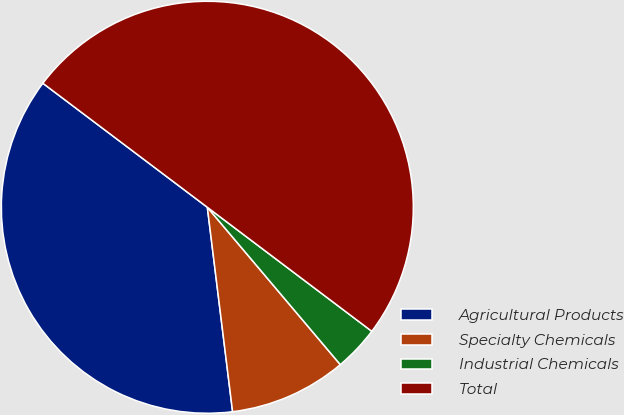Convert chart. <chart><loc_0><loc_0><loc_500><loc_500><pie_chart><fcel>Agricultural Products<fcel>Specialty Chemicals<fcel>Industrial Chemicals<fcel>Total<nl><fcel>37.24%<fcel>9.21%<fcel>3.55%<fcel>50.0%<nl></chart> 